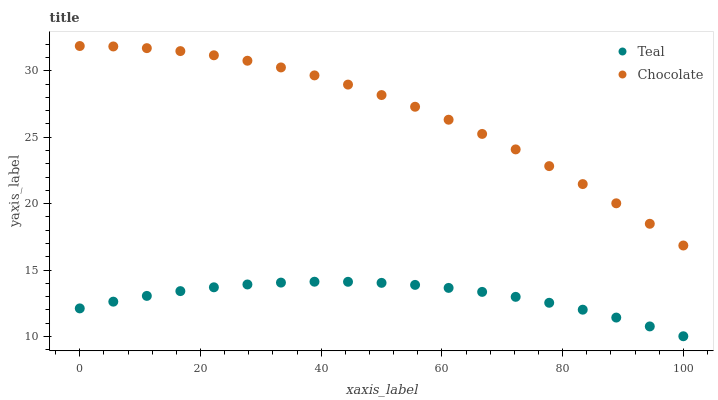Does Teal have the minimum area under the curve?
Answer yes or no. Yes. Does Chocolate have the maximum area under the curve?
Answer yes or no. Yes. Does Chocolate have the minimum area under the curve?
Answer yes or no. No. Is Teal the smoothest?
Answer yes or no. Yes. Is Chocolate the roughest?
Answer yes or no. Yes. Is Chocolate the smoothest?
Answer yes or no. No. Does Teal have the lowest value?
Answer yes or no. Yes. Does Chocolate have the lowest value?
Answer yes or no. No. Does Chocolate have the highest value?
Answer yes or no. Yes. Is Teal less than Chocolate?
Answer yes or no. Yes. Is Chocolate greater than Teal?
Answer yes or no. Yes. Does Teal intersect Chocolate?
Answer yes or no. No. 